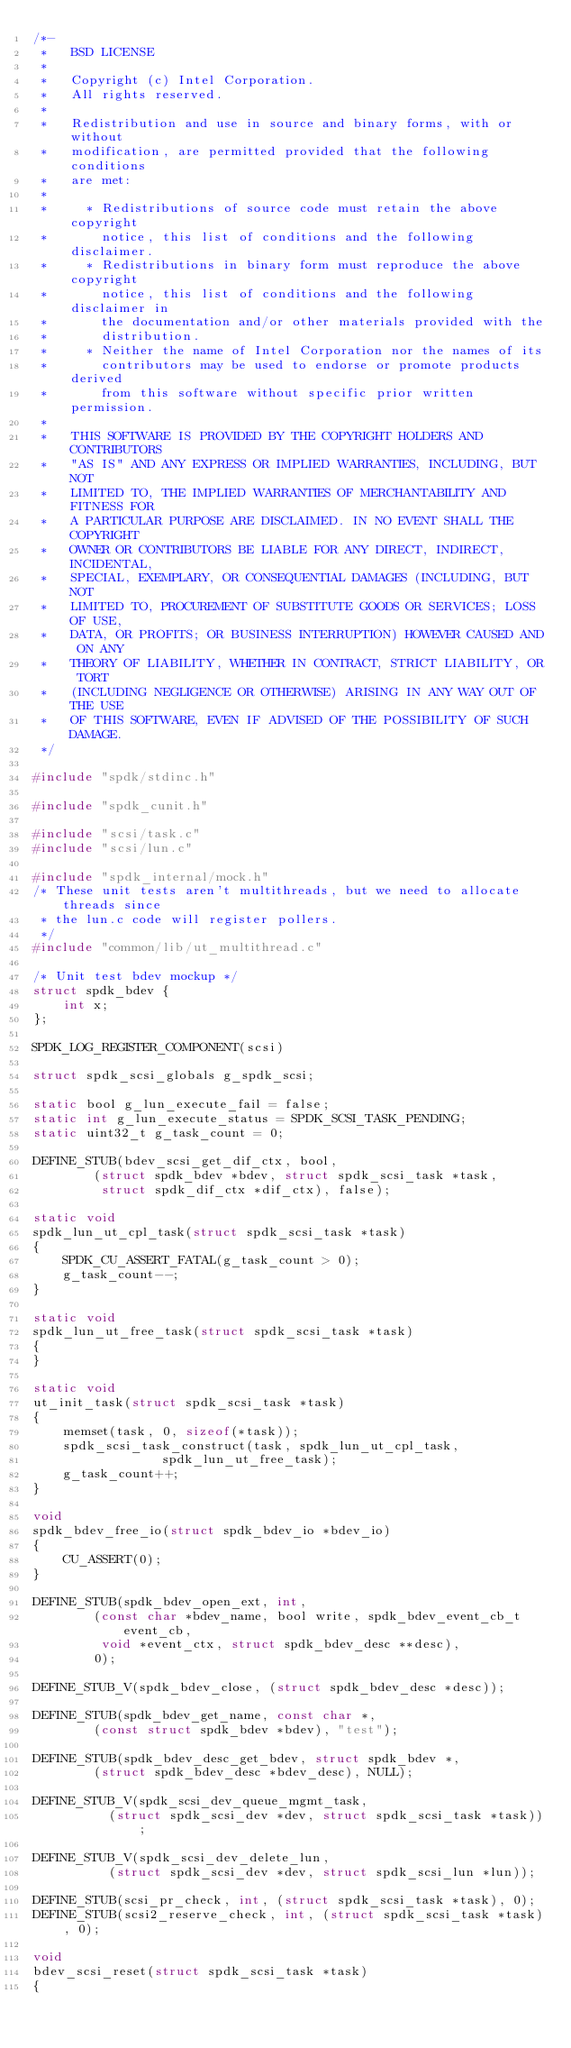<code> <loc_0><loc_0><loc_500><loc_500><_C_>/*-
 *   BSD LICENSE
 *
 *   Copyright (c) Intel Corporation.
 *   All rights reserved.
 *
 *   Redistribution and use in source and binary forms, with or without
 *   modification, are permitted provided that the following conditions
 *   are met:
 *
 *     * Redistributions of source code must retain the above copyright
 *       notice, this list of conditions and the following disclaimer.
 *     * Redistributions in binary form must reproduce the above copyright
 *       notice, this list of conditions and the following disclaimer in
 *       the documentation and/or other materials provided with the
 *       distribution.
 *     * Neither the name of Intel Corporation nor the names of its
 *       contributors may be used to endorse or promote products derived
 *       from this software without specific prior written permission.
 *
 *   THIS SOFTWARE IS PROVIDED BY THE COPYRIGHT HOLDERS AND CONTRIBUTORS
 *   "AS IS" AND ANY EXPRESS OR IMPLIED WARRANTIES, INCLUDING, BUT NOT
 *   LIMITED TO, THE IMPLIED WARRANTIES OF MERCHANTABILITY AND FITNESS FOR
 *   A PARTICULAR PURPOSE ARE DISCLAIMED. IN NO EVENT SHALL THE COPYRIGHT
 *   OWNER OR CONTRIBUTORS BE LIABLE FOR ANY DIRECT, INDIRECT, INCIDENTAL,
 *   SPECIAL, EXEMPLARY, OR CONSEQUENTIAL DAMAGES (INCLUDING, BUT NOT
 *   LIMITED TO, PROCUREMENT OF SUBSTITUTE GOODS OR SERVICES; LOSS OF USE,
 *   DATA, OR PROFITS; OR BUSINESS INTERRUPTION) HOWEVER CAUSED AND ON ANY
 *   THEORY OF LIABILITY, WHETHER IN CONTRACT, STRICT LIABILITY, OR TORT
 *   (INCLUDING NEGLIGENCE OR OTHERWISE) ARISING IN ANY WAY OUT OF THE USE
 *   OF THIS SOFTWARE, EVEN IF ADVISED OF THE POSSIBILITY OF SUCH DAMAGE.
 */

#include "spdk/stdinc.h"

#include "spdk_cunit.h"

#include "scsi/task.c"
#include "scsi/lun.c"

#include "spdk_internal/mock.h"
/* These unit tests aren't multithreads, but we need to allocate threads since
 * the lun.c code will register pollers.
 */
#include "common/lib/ut_multithread.c"

/* Unit test bdev mockup */
struct spdk_bdev {
	int x;
};

SPDK_LOG_REGISTER_COMPONENT(scsi)

struct spdk_scsi_globals g_spdk_scsi;

static bool g_lun_execute_fail = false;
static int g_lun_execute_status = SPDK_SCSI_TASK_PENDING;
static uint32_t g_task_count = 0;

DEFINE_STUB(bdev_scsi_get_dif_ctx, bool,
	    (struct spdk_bdev *bdev, struct spdk_scsi_task *task,
	     struct spdk_dif_ctx *dif_ctx), false);

static void
spdk_lun_ut_cpl_task(struct spdk_scsi_task *task)
{
	SPDK_CU_ASSERT_FATAL(g_task_count > 0);
	g_task_count--;
}

static void
spdk_lun_ut_free_task(struct spdk_scsi_task *task)
{
}

static void
ut_init_task(struct spdk_scsi_task *task)
{
	memset(task, 0, sizeof(*task));
	spdk_scsi_task_construct(task, spdk_lun_ut_cpl_task,
				 spdk_lun_ut_free_task);
	g_task_count++;
}

void
spdk_bdev_free_io(struct spdk_bdev_io *bdev_io)
{
	CU_ASSERT(0);
}

DEFINE_STUB(spdk_bdev_open_ext, int,
	    (const char *bdev_name, bool write, spdk_bdev_event_cb_t event_cb,
	     void *event_ctx, struct spdk_bdev_desc **desc),
	    0);

DEFINE_STUB_V(spdk_bdev_close, (struct spdk_bdev_desc *desc));

DEFINE_STUB(spdk_bdev_get_name, const char *,
	    (const struct spdk_bdev *bdev), "test");

DEFINE_STUB(spdk_bdev_desc_get_bdev, struct spdk_bdev *,
	    (struct spdk_bdev_desc *bdev_desc), NULL);

DEFINE_STUB_V(spdk_scsi_dev_queue_mgmt_task,
	      (struct spdk_scsi_dev *dev, struct spdk_scsi_task *task));

DEFINE_STUB_V(spdk_scsi_dev_delete_lun,
	      (struct spdk_scsi_dev *dev, struct spdk_scsi_lun *lun));

DEFINE_STUB(scsi_pr_check, int, (struct spdk_scsi_task *task), 0);
DEFINE_STUB(scsi2_reserve_check, int, (struct spdk_scsi_task *task), 0);

void
bdev_scsi_reset(struct spdk_scsi_task *task)
{</code> 